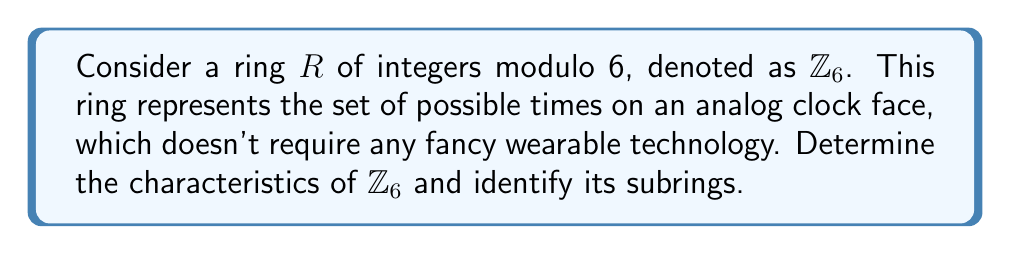Help me with this question. Let's approach this step-by-step:

1) First, we need to understand the elements of $\mathbb{Z}_6$:
   $\mathbb{Z}_6 = \{0, 1, 2, 3, 4, 5\}$

2) Characteristics of $\mathbb{Z}_6$:
   a) It's a commutative ring with unity (1).
   b) Addition and multiplication are performed modulo 6.
   c) The additive identity is 0.
   d) The multiplicative identity is 1.
   e) Every element has an additive inverse:
      0 + 0 ≡ 0 (mod 6)
      1 + 5 ≡ 0 (mod 6)
      2 + 4 ≡ 0 (mod 6)
      3 + 3 ≡ 0 (mod 6)
   f) Not every non-zero element has a multiplicative inverse. For example, 2 and 3 don't have multiplicative inverses in $\mathbb{Z}_6$.
   g) $\mathbb{Z}_6$ has zero divisors: 2 × 3 ≡ 0 (mod 6), 3 × 4 ≡ 0 (mod 6)

3) To find the subrings, we need to identify subsets that are closed under addition and multiplication, and contain the additive inverse of each element:

   a) {0} is always a subring (the trivial subring).
   b) {0, 2, 4} forms a subring:
      Addition table:
      $$ \begin{array}{c|ccc}
         + & 0 & 2 & 4 \\
         \hline
         0 & 0 & 2 & 4 \\
         2 & 2 & 4 & 0 \\
         4 & 4 & 0 & 2
      \end{array} $$
      Multiplication table:
      $$ \begin{array}{c|ccc}
         × & 0 & 2 & 4 \\
         \hline
         0 & 0 & 0 & 0 \\
         2 & 0 & 4 & 2 \\
         4 & 0 & 2 & 4
      \end{array} $$
   c) {0, 3} forms a subring:
      Addition table:
      $$ \begin{array}{c|cc}
         + & 0 & 3 \\
         \hline
         0 & 0 & 3 \\
         3 & 3 & 0
      \end{array} $$
      Multiplication table:
      $$ \begin{array}{c|cc}
         × & 0 & 3 \\
         \hline
         0 & 0 & 0 \\
         3 & 0 & 3
      \end{array} $$
   d) $\mathbb{Z}_6$ itself is a subring (the improper subring).

These are all the subrings of $\mathbb{Z}_6$.
Answer: The characteristics of $\mathbb{Z}_6$ are: commutative ring with unity, has zero divisors, not all non-zero elements have multiplicative inverses. The subrings of $\mathbb{Z}_6$ are {0}, {0, 2, 4}, {0, 3}, and $\mathbb{Z}_6$ itself. 